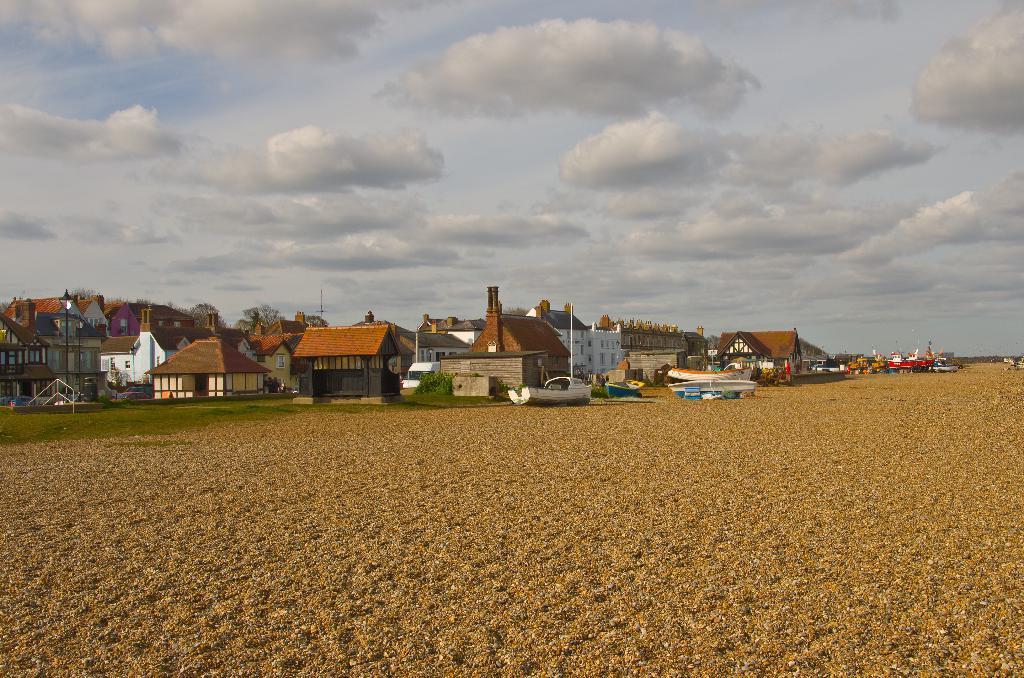Describe this image in one or two sentences. In the middle I can see grass, houses, buildings and boats on the ground. At the top I can see the sky. This image is taken may be near the sandy beach. 